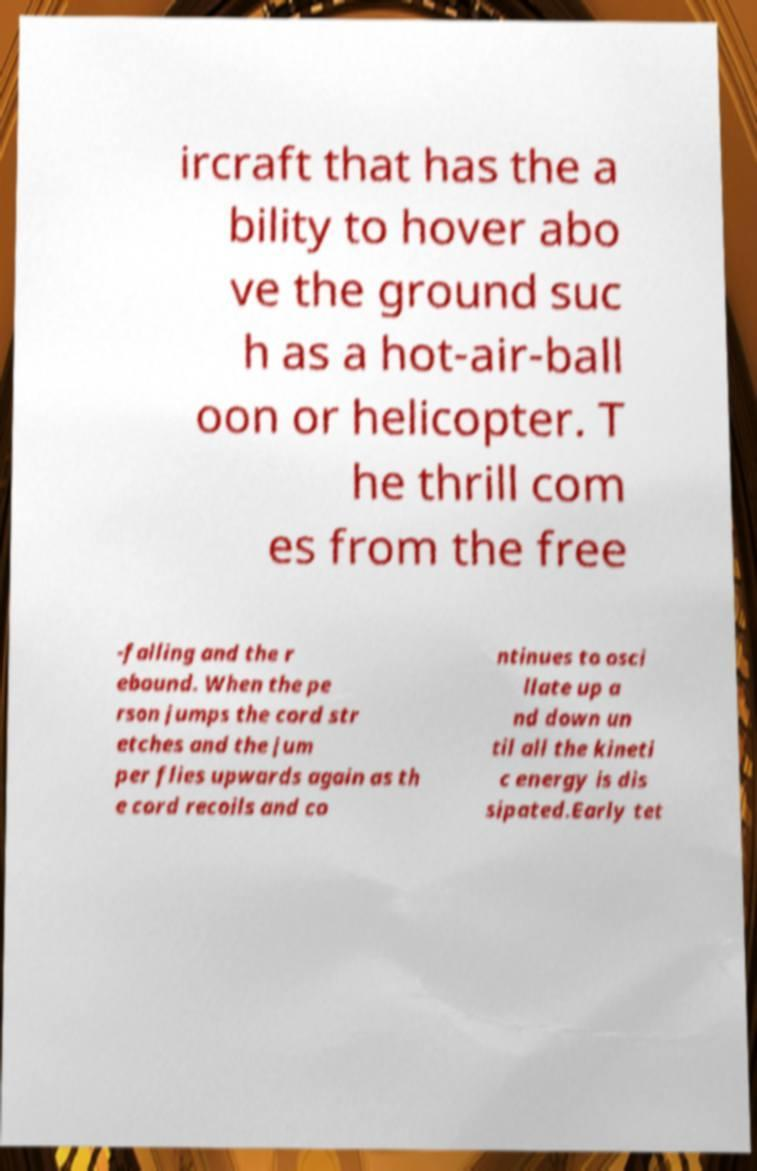For documentation purposes, I need the text within this image transcribed. Could you provide that? ircraft that has the a bility to hover abo ve the ground suc h as a hot-air-ball oon or helicopter. T he thrill com es from the free -falling and the r ebound. When the pe rson jumps the cord str etches and the jum per flies upwards again as th e cord recoils and co ntinues to osci llate up a nd down un til all the kineti c energy is dis sipated.Early tet 